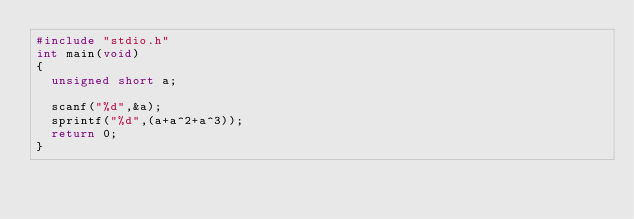<code> <loc_0><loc_0><loc_500><loc_500><_C_>#include "stdio.h"
int main(void)
{
  unsigned short a;
  
  scanf("%d",&a);
  sprintf("%d",(a+a^2+a^3));
  return 0;
}</code> 